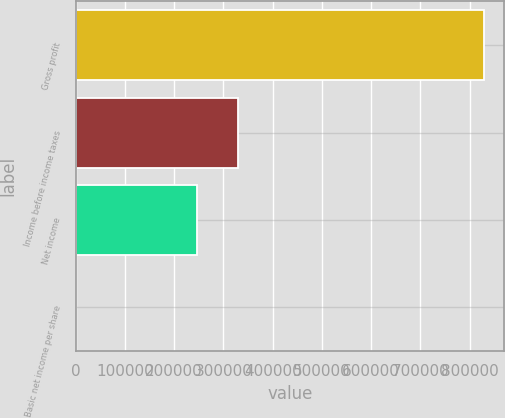<chart> <loc_0><loc_0><loc_500><loc_500><bar_chart><fcel>Gross profit<fcel>Income before income taxes<fcel>Net income<fcel>Basic net income per share<nl><fcel>828863<fcel>328803<fcel>245917<fcel>0.47<nl></chart> 